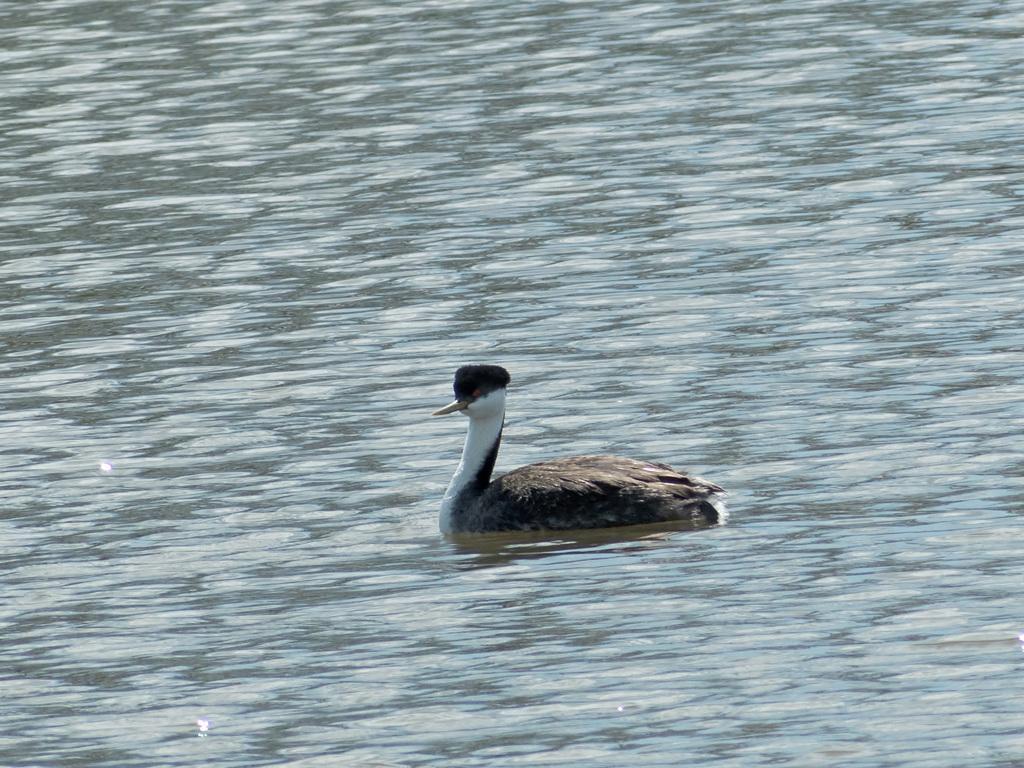Could you give a brief overview of what you see in this image? A western grebe is swimming on the water. 